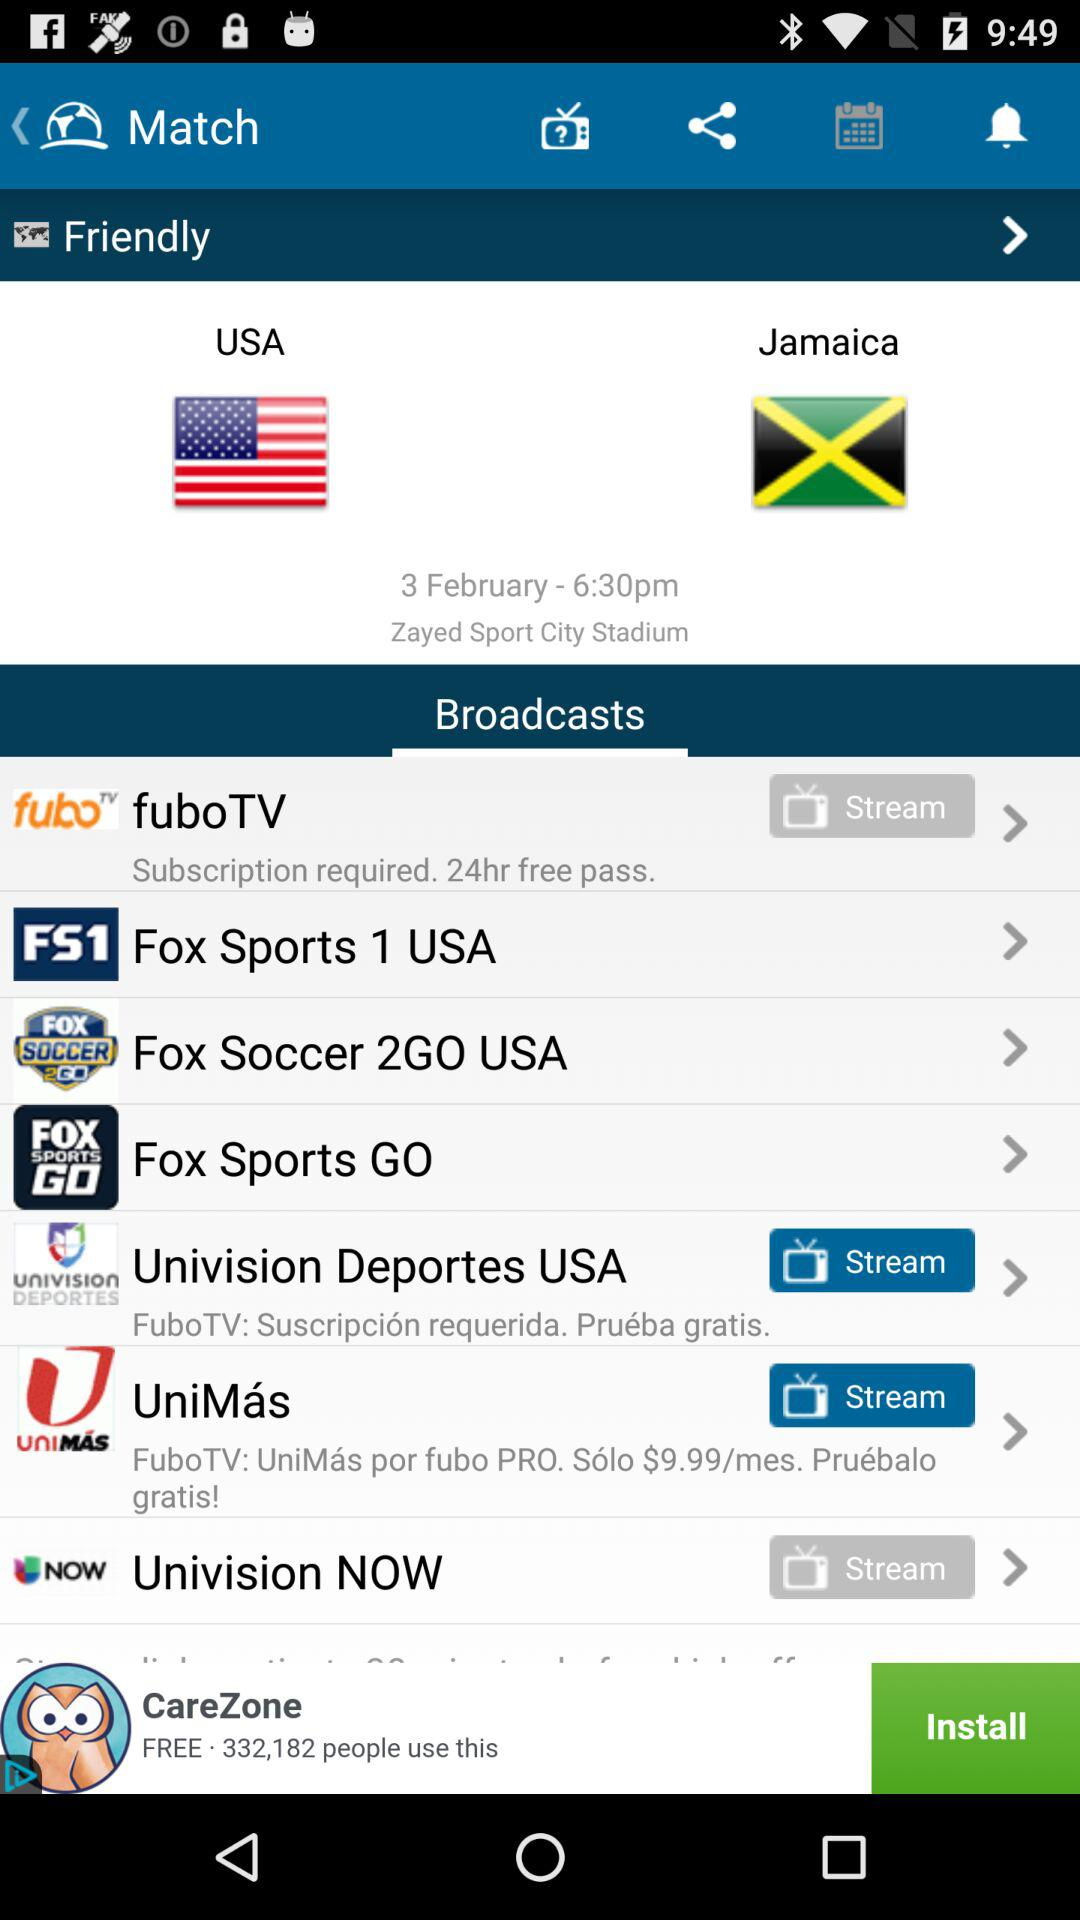Who are the broadcasters of the match between "USA" and "Jamaica"? The broadcasters of the match are "fuboTV", "Fox Sports 1 USA", "Fox Soccer 2GO USA", "Fox Sports GO","Univision Deportes USA", "UniMás" and "Univision NOW". 